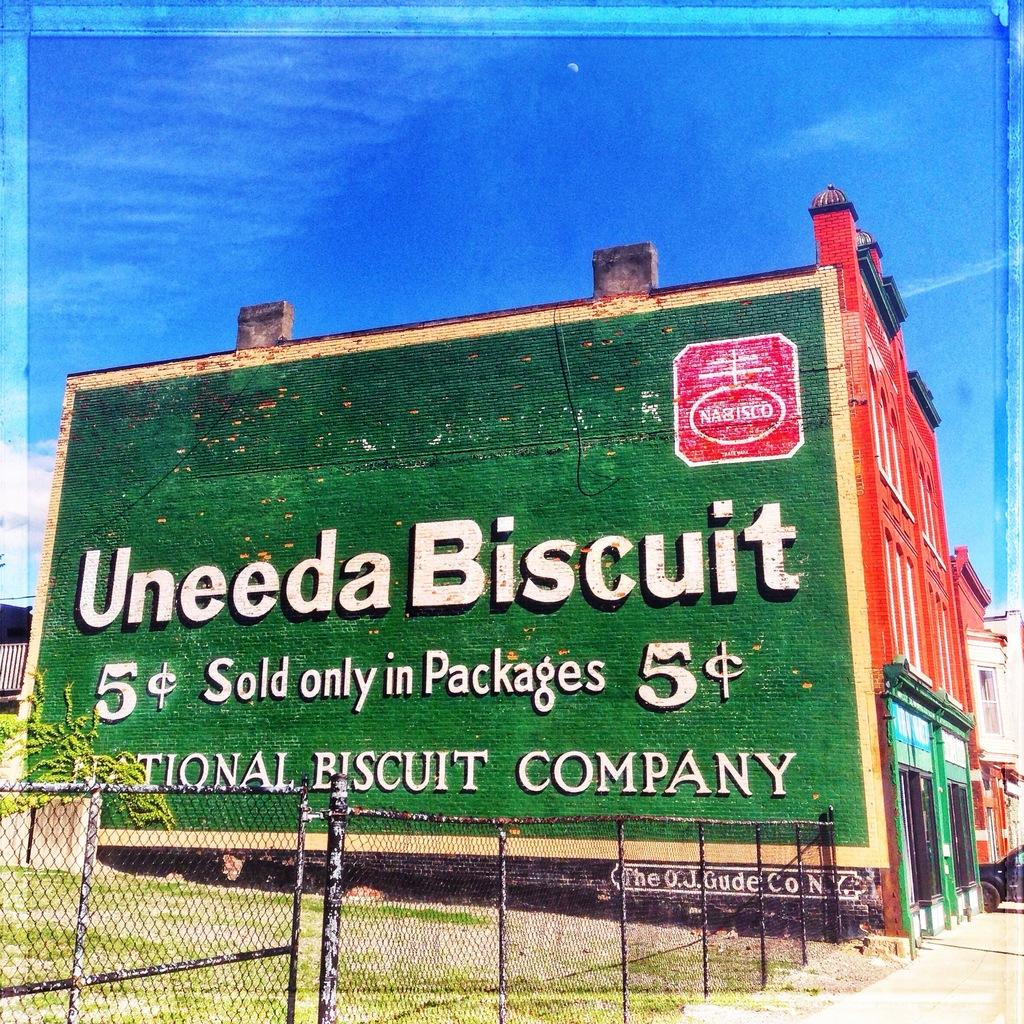Provide a one-sentence caption for the provided image. A huge advert adorns the side of a building telling us about nabisco Uneeda Biscuits. 